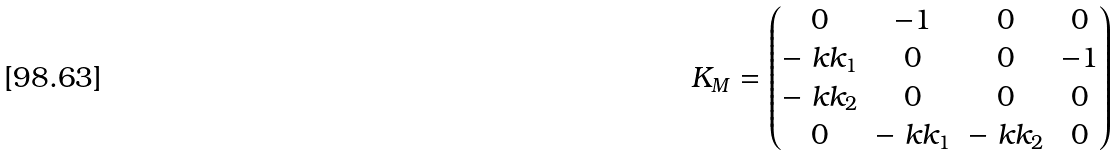Convert formula to latex. <formula><loc_0><loc_0><loc_500><loc_500>K _ { M } = \begin{pmatrix} 0 & - 1 & 0 & 0 \\ - \ k k _ { 1 } & 0 & 0 & - 1 \\ - \ k k _ { 2 } & 0 & 0 & 0 \\ 0 & - \ k k _ { 1 } & - \ k k _ { 2 } & 0 \end{pmatrix}</formula> 